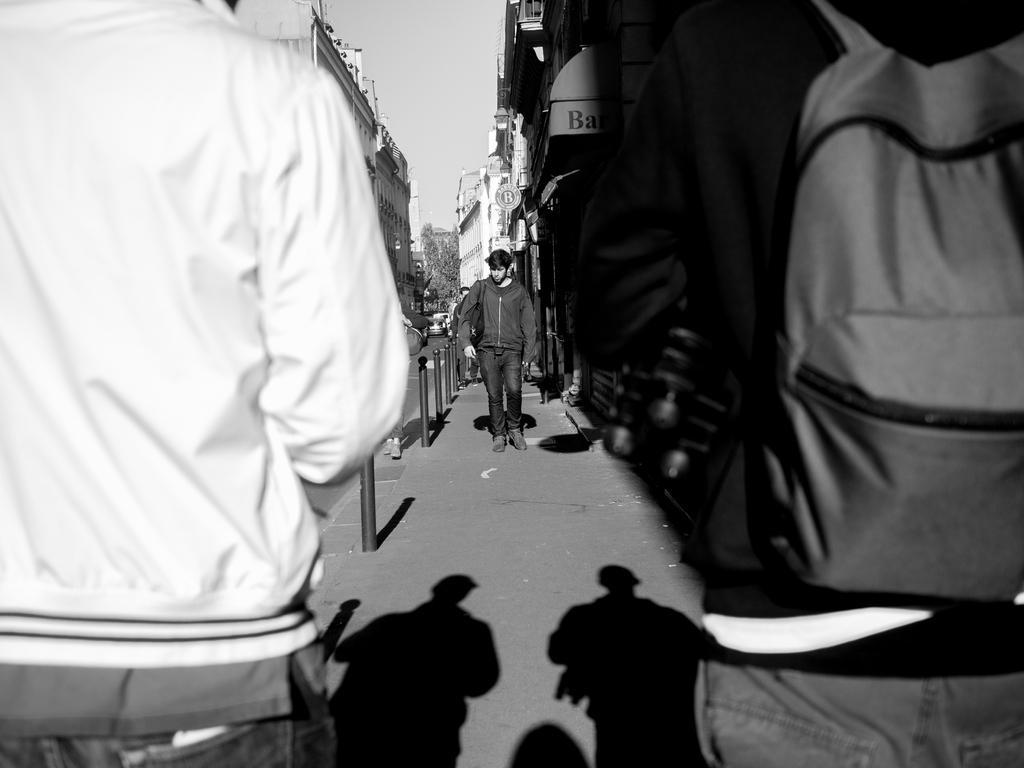Please provide a concise description of this image. This is a black and white image. There are a few people. We can see the ground with some objects. There are a few buildings and trees. We can also see some boards with text. We can see some poles and the shadows of a few people on the ground. We can also see the sky. 